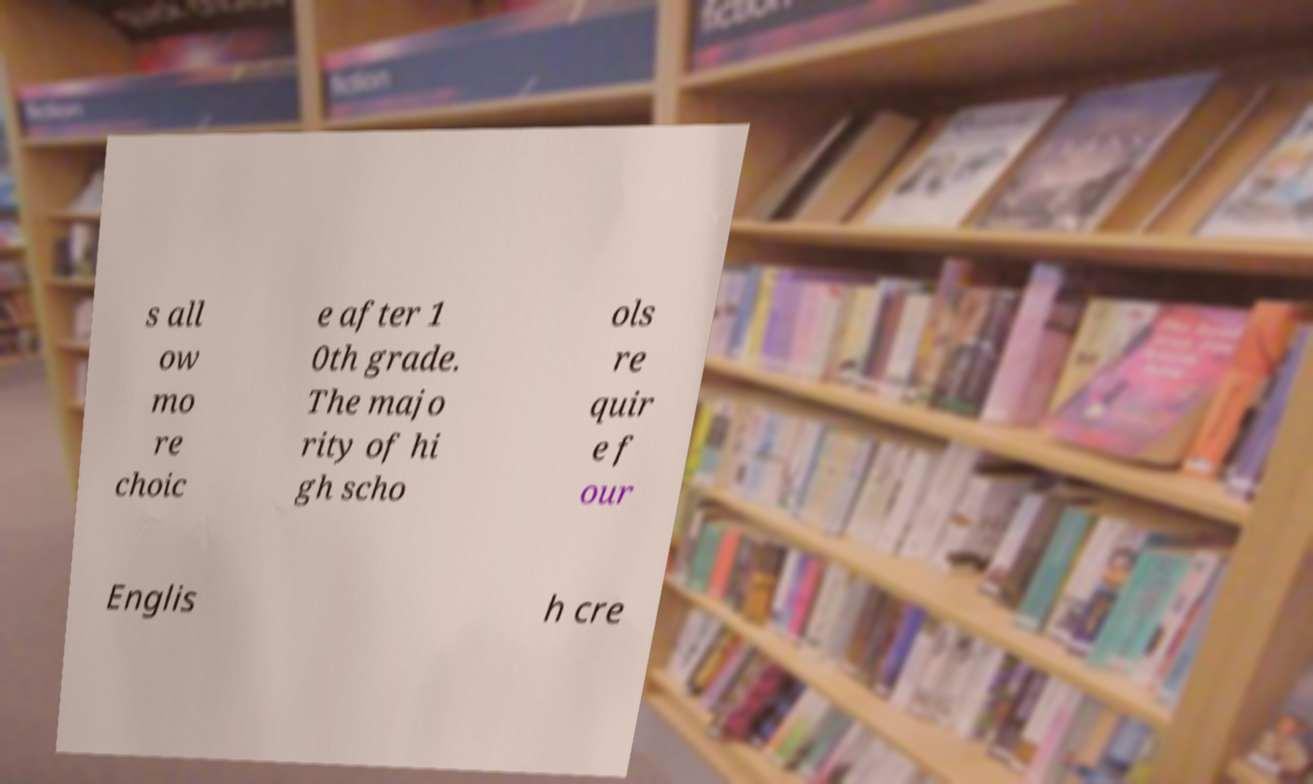For documentation purposes, I need the text within this image transcribed. Could you provide that? s all ow mo re choic e after 1 0th grade. The majo rity of hi gh scho ols re quir e f our Englis h cre 